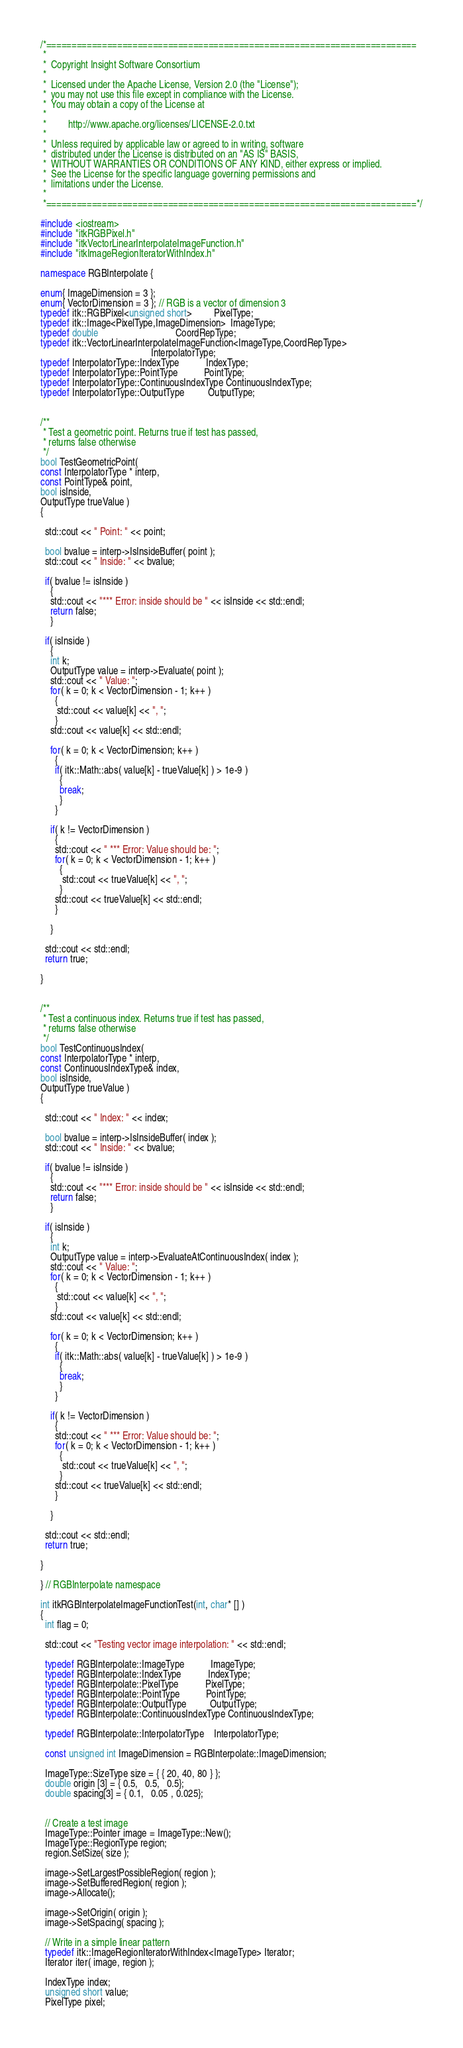<code> <loc_0><loc_0><loc_500><loc_500><_C++_>/*=========================================================================
 *
 *  Copyright Insight Software Consortium
 *
 *  Licensed under the Apache License, Version 2.0 (the "License");
 *  you may not use this file except in compliance with the License.
 *  You may obtain a copy of the License at
 *
 *         http://www.apache.org/licenses/LICENSE-2.0.txt
 *
 *  Unless required by applicable law or agreed to in writing, software
 *  distributed under the License is distributed on an "AS IS" BASIS,
 *  WITHOUT WARRANTIES OR CONDITIONS OF ANY KIND, either express or implied.
 *  See the License for the specific language governing permissions and
 *  limitations under the License.
 *
 *=========================================================================*/

#include <iostream>
#include "itkRGBPixel.h"
#include "itkVectorLinearInterpolateImageFunction.h"
#include "itkImageRegionIteratorWithIndex.h"

namespace RGBInterpolate {

enum{ ImageDimension = 3 };
enum{ VectorDimension = 3 }; // RGB is a vector of dimension 3
typedef itk::RGBPixel<unsigned short>         PixelType;
typedef itk::Image<PixelType,ImageDimension>  ImageType;
typedef double                                CoordRepType;
typedef itk::VectorLinearInterpolateImageFunction<ImageType,CoordRepType>
                                              InterpolatorType;
typedef InterpolatorType::IndexType           IndexType;
typedef InterpolatorType::PointType           PointType;
typedef InterpolatorType::ContinuousIndexType ContinuousIndexType;
typedef InterpolatorType::OutputType          OutputType;


/**
 * Test a geometric point. Returns true if test has passed,
 * returns false otherwise
 */
bool TestGeometricPoint(
const InterpolatorType * interp,
const PointType& point,
bool isInside,
OutputType trueValue )
{

  std::cout << " Point: " << point;

  bool bvalue = interp->IsInsideBuffer( point );
  std::cout << " Inside: " << bvalue;

  if( bvalue != isInside )
    {
    std::cout << "*** Error: inside should be " << isInside << std::endl;
    return false;
    }

  if( isInside )
    {
    int k;
    OutputType value = interp->Evaluate( point );
    std::cout << " Value: ";
    for( k = 0; k < VectorDimension - 1; k++ )
      {
       std::cout << value[k] << ", ";
      }
    std::cout << value[k] << std::endl;

    for( k = 0; k < VectorDimension; k++ )
      {
      if( itk::Math::abs( value[k] - trueValue[k] ) > 1e-9 )
        {
        break;
        }
      }

    if( k != VectorDimension )
      {
      std::cout << " *** Error: Value should be: ";
      for( k = 0; k < VectorDimension - 1; k++ )
        {
         std::cout << trueValue[k] << ", ";
        }
      std::cout << trueValue[k] << std::endl;
      }

    }

  std::cout << std::endl;
  return true;

}


/**
 * Test a continuous index. Returns true if test has passed,
 * returns false otherwise
 */
bool TestContinuousIndex(
const InterpolatorType * interp,
const ContinuousIndexType& index,
bool isInside,
OutputType trueValue )
{

  std::cout << " Index: " << index;

  bool bvalue = interp->IsInsideBuffer( index );
  std::cout << " Inside: " << bvalue;

  if( bvalue != isInside )
    {
    std::cout << "*** Error: inside should be " << isInside << std::endl;
    return false;
    }

  if( isInside )
    {
    int k;
    OutputType value = interp->EvaluateAtContinuousIndex( index );
    std::cout << " Value: ";
    for( k = 0; k < VectorDimension - 1; k++ )
      {
       std::cout << value[k] << ", ";
      }
    std::cout << value[k] << std::endl;

    for( k = 0; k < VectorDimension; k++ )
      {
      if( itk::Math::abs( value[k] - trueValue[k] ) > 1e-9 )
        {
        break;
        }
      }

    if( k != VectorDimension )
      {
      std::cout << " *** Error: Value should be: ";
      for( k = 0; k < VectorDimension - 1; k++ )
        {
         std::cout << trueValue[k] << ", ";
        }
      std::cout << trueValue[k] << std::endl;
      }

    }

  std::cout << std::endl;
  return true;

}

} // RGBInterpolate namespace

int itkRGBInterpolateImageFunctionTest(int, char* [] )
{
  int flag = 0;

  std::cout << "Testing vector image interpolation: " << std::endl;

  typedef RGBInterpolate::ImageType           ImageType;
  typedef RGBInterpolate::IndexType           IndexType;
  typedef RGBInterpolate::PixelType           PixelType;
  typedef RGBInterpolate::PointType           PointType;
  typedef RGBInterpolate::OutputType          OutputType;
  typedef RGBInterpolate::ContinuousIndexType ContinuousIndexType;

  typedef RGBInterpolate::InterpolatorType    InterpolatorType;

  const unsigned int ImageDimension = RGBInterpolate::ImageDimension;

  ImageType::SizeType size = { { 20, 40, 80 } };
  double origin [3] = { 0.5,   0.5,   0.5};
  double spacing[3] = { 0.1,   0.05 , 0.025};


  // Create a test image
  ImageType::Pointer image = ImageType::New();
  ImageType::RegionType region;
  region.SetSize( size );

  image->SetLargestPossibleRegion( region );
  image->SetBufferedRegion( region );
  image->Allocate();

  image->SetOrigin( origin );
  image->SetSpacing( spacing );

  // Write in a simple linear pattern
  typedef itk::ImageRegionIteratorWithIndex<ImageType> Iterator;
  Iterator iter( image, region );

  IndexType index;
  unsigned short value;
  PixelType pixel;
</code> 